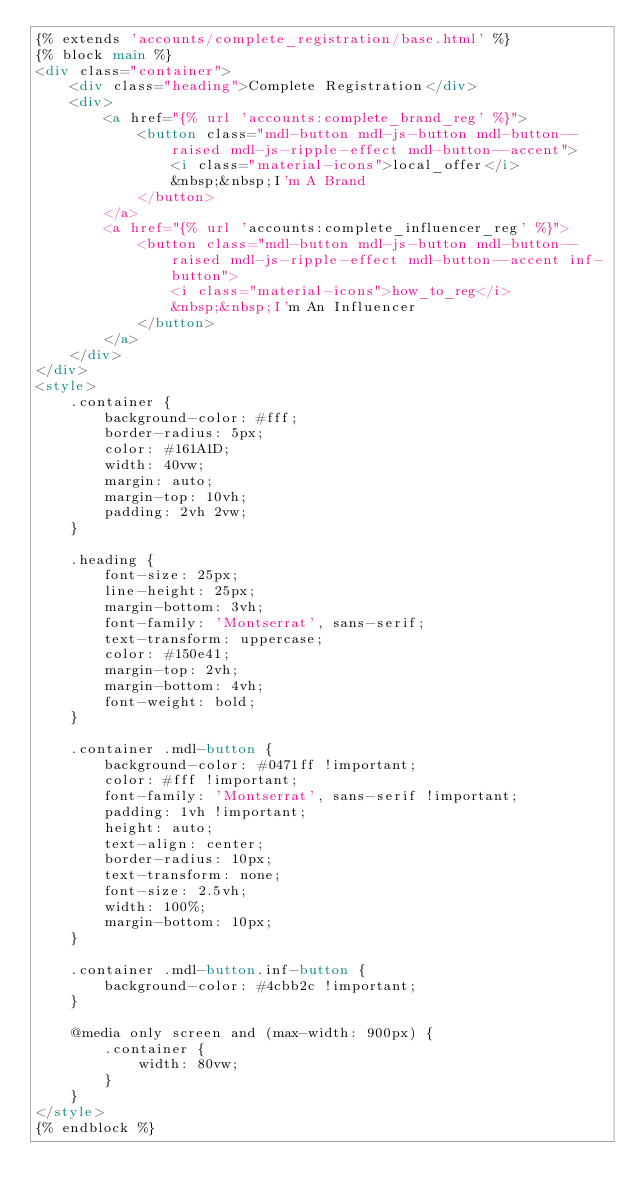<code> <loc_0><loc_0><loc_500><loc_500><_HTML_>{% extends 'accounts/complete_registration/base.html' %}
{% block main %}
<div class="container">
    <div class="heading">Complete Registration</div>
    <div>
        <a href="{% url 'accounts:complete_brand_reg' %}">
            <button class="mdl-button mdl-js-button mdl-button--raised mdl-js-ripple-effect mdl-button--accent">
                <i class="material-icons">local_offer</i>
                &nbsp;&nbsp;I'm A Brand
            </button>
        </a>
        <a href="{% url 'accounts:complete_influencer_reg' %}">
            <button class="mdl-button mdl-js-button mdl-button--raised mdl-js-ripple-effect mdl-button--accent inf-button">
                <i class="material-icons">how_to_reg</i>
                &nbsp;&nbsp;I'm An Influencer
            </button>
        </a>
    </div>
</div>
<style>
    .container {
        background-color: #fff;
        border-radius: 5px;
        color: #161A1D;
        width: 40vw;
        margin: auto;
        margin-top: 10vh;
        padding: 2vh 2vw;
    }

    .heading {
        font-size: 25px;
        line-height: 25px;
        margin-bottom: 3vh;
        font-family: 'Montserrat', sans-serif;
        text-transform: uppercase;
        color: #150e41;
        margin-top: 2vh;
        margin-bottom: 4vh;
        font-weight: bold;
    }

    .container .mdl-button {
        background-color: #0471ff !important;
        color: #fff !important;
        font-family: 'Montserrat', sans-serif !important;
        padding: 1vh !important;
        height: auto;
        text-align: center;
        border-radius: 10px;
        text-transform: none;
        font-size: 2.5vh;
        width: 100%;
        margin-bottom: 10px;
    }

    .container .mdl-button.inf-button {
        background-color: #4cbb2c !important;
    }

    @media only screen and (max-width: 900px) {
        .container {
            width: 80vw;
        }
    }
</style>
{% endblock %}</code> 